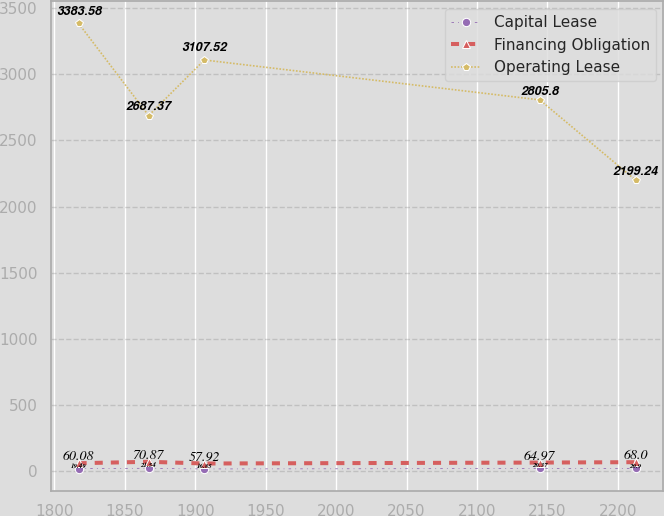<chart> <loc_0><loc_0><loc_500><loc_500><line_chart><ecel><fcel>Capital Lease<fcel>Financing Obligation<fcel>Operating Lease<nl><fcel>1817.21<fcel>19.49<fcel>60.08<fcel>3383.58<nl><fcel>1866.92<fcel>21.54<fcel>70.87<fcel>2687.37<nl><fcel>1906.46<fcel>16.85<fcel>57.92<fcel>3107.52<nl><fcel>2144.57<fcel>20.37<fcel>64.97<fcel>2805.8<nl><fcel>2212.57<fcel>20.9<fcel>68<fcel>2199.24<nl></chart> 